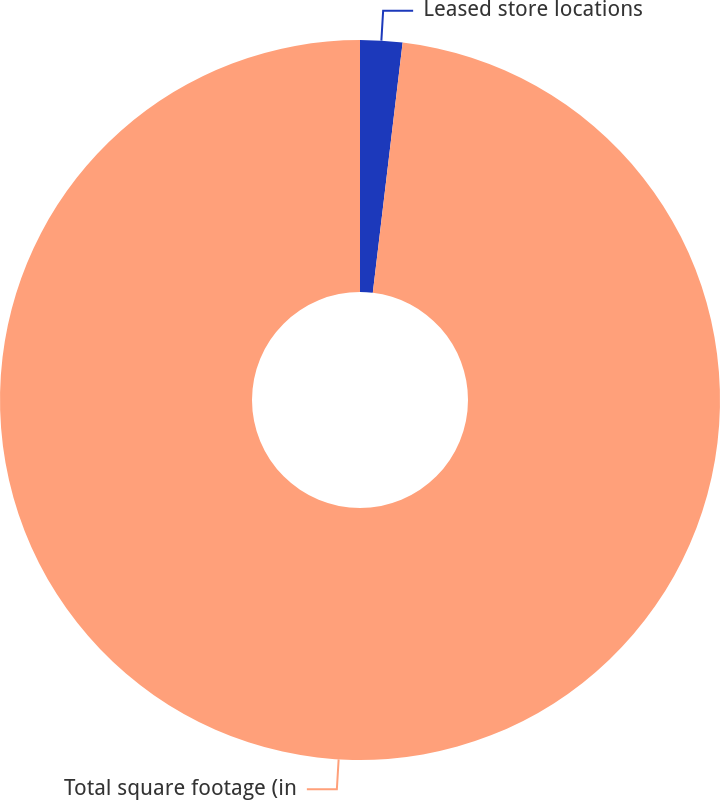<chart> <loc_0><loc_0><loc_500><loc_500><pie_chart><fcel>Leased store locations<fcel>Total square footage (in<nl><fcel>1.89%<fcel>98.11%<nl></chart> 